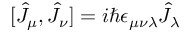Convert formula to latex. <formula><loc_0><loc_0><loc_500><loc_500>[ \hat { J } _ { \mu } , \hat { J } _ { \nu } ] = i \hbar { \epsilon } _ { \mu \nu \lambda } \hat { J } _ { \lambda }</formula> 